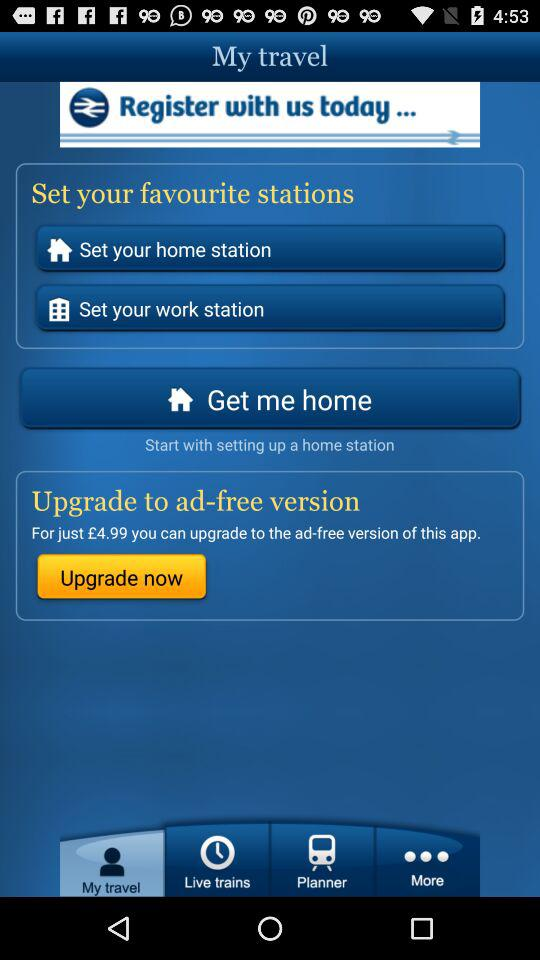What is the application name? The application name is "My travel". 